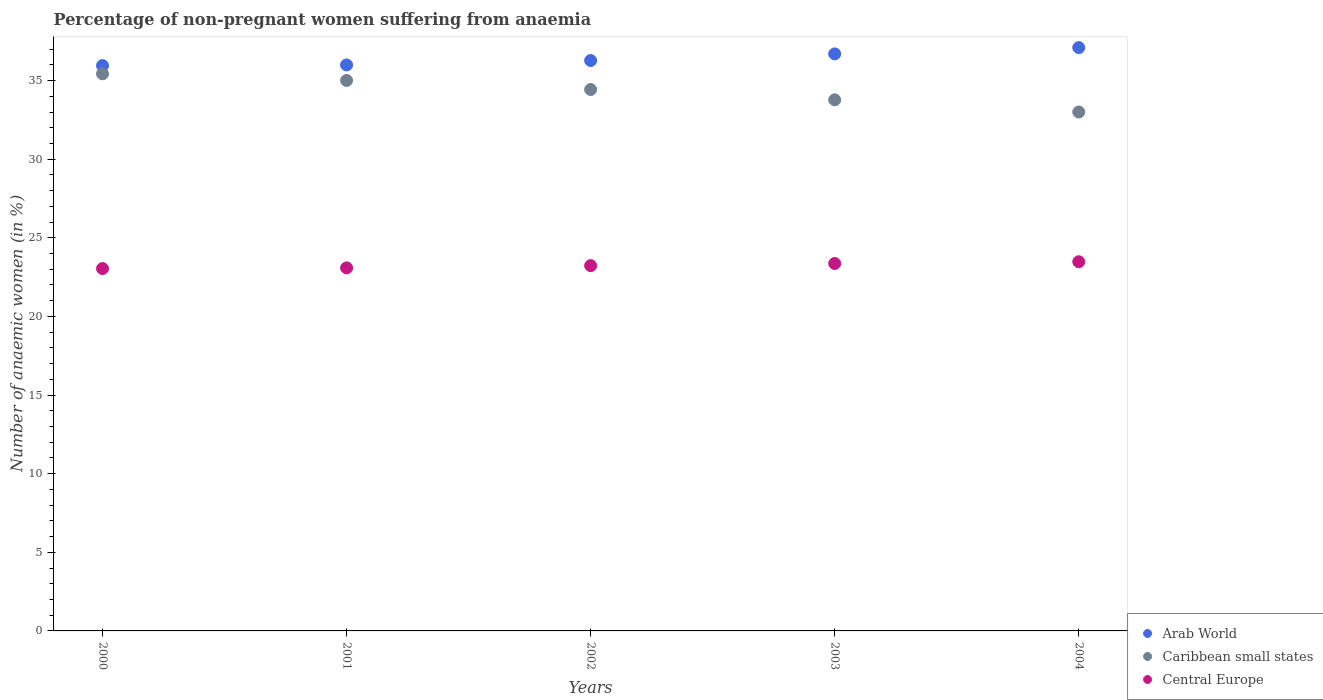What is the percentage of non-pregnant women suffering from anaemia in Arab World in 2000?
Your answer should be compact. 35.95. Across all years, what is the maximum percentage of non-pregnant women suffering from anaemia in Caribbean small states?
Offer a very short reply. 35.43. Across all years, what is the minimum percentage of non-pregnant women suffering from anaemia in Central Europe?
Give a very brief answer. 23.04. In which year was the percentage of non-pregnant women suffering from anaemia in Central Europe minimum?
Offer a terse response. 2000. What is the total percentage of non-pregnant women suffering from anaemia in Caribbean small states in the graph?
Provide a succinct answer. 171.65. What is the difference between the percentage of non-pregnant women suffering from anaemia in Central Europe in 2000 and that in 2003?
Provide a short and direct response. -0.32. What is the difference between the percentage of non-pregnant women suffering from anaemia in Arab World in 2002 and the percentage of non-pregnant women suffering from anaemia in Central Europe in 2000?
Provide a short and direct response. 13.23. What is the average percentage of non-pregnant women suffering from anaemia in Caribbean small states per year?
Your answer should be very brief. 34.33. In the year 2004, what is the difference between the percentage of non-pregnant women suffering from anaemia in Caribbean small states and percentage of non-pregnant women suffering from anaemia in Arab World?
Make the answer very short. -4.09. In how many years, is the percentage of non-pregnant women suffering from anaemia in Caribbean small states greater than 3 %?
Ensure brevity in your answer.  5. What is the ratio of the percentage of non-pregnant women suffering from anaemia in Central Europe in 2001 to that in 2003?
Offer a very short reply. 0.99. Is the difference between the percentage of non-pregnant women suffering from anaemia in Caribbean small states in 2002 and 2004 greater than the difference between the percentage of non-pregnant women suffering from anaemia in Arab World in 2002 and 2004?
Your response must be concise. Yes. What is the difference between the highest and the second highest percentage of non-pregnant women suffering from anaemia in Arab World?
Make the answer very short. 0.4. What is the difference between the highest and the lowest percentage of non-pregnant women suffering from anaemia in Caribbean small states?
Your answer should be compact. 2.43. In how many years, is the percentage of non-pregnant women suffering from anaemia in Arab World greater than the average percentage of non-pregnant women suffering from anaemia in Arab World taken over all years?
Your answer should be compact. 2. Is the sum of the percentage of non-pregnant women suffering from anaemia in Caribbean small states in 2000 and 2002 greater than the maximum percentage of non-pregnant women suffering from anaemia in Arab World across all years?
Make the answer very short. Yes. Is the percentage of non-pregnant women suffering from anaemia in Caribbean small states strictly greater than the percentage of non-pregnant women suffering from anaemia in Arab World over the years?
Offer a very short reply. No. What is the difference between two consecutive major ticks on the Y-axis?
Your answer should be very brief. 5. Are the values on the major ticks of Y-axis written in scientific E-notation?
Ensure brevity in your answer.  No. What is the title of the graph?
Your response must be concise. Percentage of non-pregnant women suffering from anaemia. Does "Other small states" appear as one of the legend labels in the graph?
Your answer should be very brief. No. What is the label or title of the X-axis?
Ensure brevity in your answer.  Years. What is the label or title of the Y-axis?
Make the answer very short. Number of anaemic women (in %). What is the Number of anaemic women (in %) in Arab World in 2000?
Make the answer very short. 35.95. What is the Number of anaemic women (in %) in Caribbean small states in 2000?
Ensure brevity in your answer.  35.43. What is the Number of anaemic women (in %) in Central Europe in 2000?
Give a very brief answer. 23.04. What is the Number of anaemic women (in %) in Arab World in 2001?
Offer a very short reply. 35.99. What is the Number of anaemic women (in %) of Caribbean small states in 2001?
Give a very brief answer. 35.01. What is the Number of anaemic women (in %) of Central Europe in 2001?
Make the answer very short. 23.09. What is the Number of anaemic women (in %) of Arab World in 2002?
Your response must be concise. 36.27. What is the Number of anaemic women (in %) in Caribbean small states in 2002?
Your answer should be compact. 34.43. What is the Number of anaemic women (in %) in Central Europe in 2002?
Give a very brief answer. 23.23. What is the Number of anaemic women (in %) of Arab World in 2003?
Provide a succinct answer. 36.7. What is the Number of anaemic women (in %) of Caribbean small states in 2003?
Provide a succinct answer. 33.78. What is the Number of anaemic women (in %) in Central Europe in 2003?
Offer a very short reply. 23.37. What is the Number of anaemic women (in %) in Arab World in 2004?
Make the answer very short. 37.1. What is the Number of anaemic women (in %) of Caribbean small states in 2004?
Make the answer very short. 33. What is the Number of anaemic women (in %) of Central Europe in 2004?
Keep it short and to the point. 23.48. Across all years, what is the maximum Number of anaemic women (in %) in Arab World?
Make the answer very short. 37.1. Across all years, what is the maximum Number of anaemic women (in %) in Caribbean small states?
Provide a short and direct response. 35.43. Across all years, what is the maximum Number of anaemic women (in %) of Central Europe?
Your answer should be very brief. 23.48. Across all years, what is the minimum Number of anaemic women (in %) of Arab World?
Offer a very short reply. 35.95. Across all years, what is the minimum Number of anaemic women (in %) in Caribbean small states?
Ensure brevity in your answer.  33. Across all years, what is the minimum Number of anaemic women (in %) in Central Europe?
Offer a terse response. 23.04. What is the total Number of anaemic women (in %) of Arab World in the graph?
Your response must be concise. 182.01. What is the total Number of anaemic women (in %) of Caribbean small states in the graph?
Your response must be concise. 171.65. What is the total Number of anaemic women (in %) of Central Europe in the graph?
Provide a succinct answer. 116.21. What is the difference between the Number of anaemic women (in %) in Arab World in 2000 and that in 2001?
Offer a terse response. -0.04. What is the difference between the Number of anaemic women (in %) of Caribbean small states in 2000 and that in 2001?
Provide a short and direct response. 0.43. What is the difference between the Number of anaemic women (in %) of Central Europe in 2000 and that in 2001?
Offer a very short reply. -0.04. What is the difference between the Number of anaemic women (in %) in Arab World in 2000 and that in 2002?
Provide a short and direct response. -0.32. What is the difference between the Number of anaemic women (in %) in Caribbean small states in 2000 and that in 2002?
Keep it short and to the point. 1. What is the difference between the Number of anaemic women (in %) in Central Europe in 2000 and that in 2002?
Offer a terse response. -0.19. What is the difference between the Number of anaemic women (in %) in Arab World in 2000 and that in 2003?
Your response must be concise. -0.74. What is the difference between the Number of anaemic women (in %) in Caribbean small states in 2000 and that in 2003?
Make the answer very short. 1.66. What is the difference between the Number of anaemic women (in %) in Central Europe in 2000 and that in 2003?
Offer a terse response. -0.32. What is the difference between the Number of anaemic women (in %) of Arab World in 2000 and that in 2004?
Offer a terse response. -1.14. What is the difference between the Number of anaemic women (in %) in Caribbean small states in 2000 and that in 2004?
Offer a terse response. 2.43. What is the difference between the Number of anaemic women (in %) in Central Europe in 2000 and that in 2004?
Offer a very short reply. -0.43. What is the difference between the Number of anaemic women (in %) in Arab World in 2001 and that in 2002?
Make the answer very short. -0.28. What is the difference between the Number of anaemic women (in %) in Caribbean small states in 2001 and that in 2002?
Ensure brevity in your answer.  0.58. What is the difference between the Number of anaemic women (in %) in Central Europe in 2001 and that in 2002?
Your answer should be compact. -0.14. What is the difference between the Number of anaemic women (in %) of Arab World in 2001 and that in 2003?
Provide a succinct answer. -0.7. What is the difference between the Number of anaemic women (in %) of Caribbean small states in 2001 and that in 2003?
Your response must be concise. 1.23. What is the difference between the Number of anaemic women (in %) in Central Europe in 2001 and that in 2003?
Offer a very short reply. -0.28. What is the difference between the Number of anaemic women (in %) in Arab World in 2001 and that in 2004?
Ensure brevity in your answer.  -1.1. What is the difference between the Number of anaemic women (in %) in Caribbean small states in 2001 and that in 2004?
Your answer should be very brief. 2. What is the difference between the Number of anaemic women (in %) in Central Europe in 2001 and that in 2004?
Give a very brief answer. -0.39. What is the difference between the Number of anaemic women (in %) of Arab World in 2002 and that in 2003?
Make the answer very short. -0.42. What is the difference between the Number of anaemic women (in %) of Caribbean small states in 2002 and that in 2003?
Your answer should be very brief. 0.66. What is the difference between the Number of anaemic women (in %) of Central Europe in 2002 and that in 2003?
Offer a terse response. -0.14. What is the difference between the Number of anaemic women (in %) of Arab World in 2002 and that in 2004?
Your answer should be very brief. -0.82. What is the difference between the Number of anaemic women (in %) in Caribbean small states in 2002 and that in 2004?
Ensure brevity in your answer.  1.43. What is the difference between the Number of anaemic women (in %) in Central Europe in 2002 and that in 2004?
Offer a terse response. -0.25. What is the difference between the Number of anaemic women (in %) of Arab World in 2003 and that in 2004?
Ensure brevity in your answer.  -0.4. What is the difference between the Number of anaemic women (in %) in Caribbean small states in 2003 and that in 2004?
Your response must be concise. 0.77. What is the difference between the Number of anaemic women (in %) of Central Europe in 2003 and that in 2004?
Provide a succinct answer. -0.11. What is the difference between the Number of anaemic women (in %) in Arab World in 2000 and the Number of anaemic women (in %) in Caribbean small states in 2001?
Make the answer very short. 0.95. What is the difference between the Number of anaemic women (in %) in Arab World in 2000 and the Number of anaemic women (in %) in Central Europe in 2001?
Give a very brief answer. 12.86. What is the difference between the Number of anaemic women (in %) in Caribbean small states in 2000 and the Number of anaemic women (in %) in Central Europe in 2001?
Provide a succinct answer. 12.34. What is the difference between the Number of anaemic women (in %) of Arab World in 2000 and the Number of anaemic women (in %) of Caribbean small states in 2002?
Keep it short and to the point. 1.52. What is the difference between the Number of anaemic women (in %) of Arab World in 2000 and the Number of anaemic women (in %) of Central Europe in 2002?
Give a very brief answer. 12.72. What is the difference between the Number of anaemic women (in %) of Caribbean small states in 2000 and the Number of anaemic women (in %) of Central Europe in 2002?
Ensure brevity in your answer.  12.2. What is the difference between the Number of anaemic women (in %) in Arab World in 2000 and the Number of anaemic women (in %) in Caribbean small states in 2003?
Offer a terse response. 2.18. What is the difference between the Number of anaemic women (in %) of Arab World in 2000 and the Number of anaemic women (in %) of Central Europe in 2003?
Your answer should be very brief. 12.58. What is the difference between the Number of anaemic women (in %) of Caribbean small states in 2000 and the Number of anaemic women (in %) of Central Europe in 2003?
Give a very brief answer. 12.06. What is the difference between the Number of anaemic women (in %) in Arab World in 2000 and the Number of anaemic women (in %) in Caribbean small states in 2004?
Provide a short and direct response. 2.95. What is the difference between the Number of anaemic women (in %) of Arab World in 2000 and the Number of anaemic women (in %) of Central Europe in 2004?
Provide a short and direct response. 12.47. What is the difference between the Number of anaemic women (in %) of Caribbean small states in 2000 and the Number of anaemic women (in %) of Central Europe in 2004?
Give a very brief answer. 11.95. What is the difference between the Number of anaemic women (in %) in Arab World in 2001 and the Number of anaemic women (in %) in Caribbean small states in 2002?
Your response must be concise. 1.56. What is the difference between the Number of anaemic women (in %) in Arab World in 2001 and the Number of anaemic women (in %) in Central Europe in 2002?
Provide a succinct answer. 12.76. What is the difference between the Number of anaemic women (in %) in Caribbean small states in 2001 and the Number of anaemic women (in %) in Central Europe in 2002?
Ensure brevity in your answer.  11.78. What is the difference between the Number of anaemic women (in %) of Arab World in 2001 and the Number of anaemic women (in %) of Caribbean small states in 2003?
Your response must be concise. 2.22. What is the difference between the Number of anaemic women (in %) in Arab World in 2001 and the Number of anaemic women (in %) in Central Europe in 2003?
Your answer should be compact. 12.63. What is the difference between the Number of anaemic women (in %) of Caribbean small states in 2001 and the Number of anaemic women (in %) of Central Europe in 2003?
Give a very brief answer. 11.64. What is the difference between the Number of anaemic women (in %) in Arab World in 2001 and the Number of anaemic women (in %) in Caribbean small states in 2004?
Offer a terse response. 2.99. What is the difference between the Number of anaemic women (in %) in Arab World in 2001 and the Number of anaemic women (in %) in Central Europe in 2004?
Your answer should be very brief. 12.52. What is the difference between the Number of anaemic women (in %) of Caribbean small states in 2001 and the Number of anaemic women (in %) of Central Europe in 2004?
Your answer should be compact. 11.53. What is the difference between the Number of anaemic women (in %) of Arab World in 2002 and the Number of anaemic women (in %) of Caribbean small states in 2003?
Your answer should be compact. 2.5. What is the difference between the Number of anaemic women (in %) of Arab World in 2002 and the Number of anaemic women (in %) of Central Europe in 2003?
Ensure brevity in your answer.  12.91. What is the difference between the Number of anaemic women (in %) of Caribbean small states in 2002 and the Number of anaemic women (in %) of Central Europe in 2003?
Keep it short and to the point. 11.06. What is the difference between the Number of anaemic women (in %) of Arab World in 2002 and the Number of anaemic women (in %) of Caribbean small states in 2004?
Offer a very short reply. 3.27. What is the difference between the Number of anaemic women (in %) in Arab World in 2002 and the Number of anaemic women (in %) in Central Europe in 2004?
Your answer should be very brief. 12.8. What is the difference between the Number of anaemic women (in %) of Caribbean small states in 2002 and the Number of anaemic women (in %) of Central Europe in 2004?
Offer a terse response. 10.95. What is the difference between the Number of anaemic women (in %) of Arab World in 2003 and the Number of anaemic women (in %) of Caribbean small states in 2004?
Your answer should be very brief. 3.69. What is the difference between the Number of anaemic women (in %) in Arab World in 2003 and the Number of anaemic women (in %) in Central Europe in 2004?
Provide a succinct answer. 13.22. What is the difference between the Number of anaemic women (in %) in Caribbean small states in 2003 and the Number of anaemic women (in %) in Central Europe in 2004?
Your answer should be very brief. 10.3. What is the average Number of anaemic women (in %) in Arab World per year?
Your response must be concise. 36.4. What is the average Number of anaemic women (in %) in Caribbean small states per year?
Keep it short and to the point. 34.33. What is the average Number of anaemic women (in %) of Central Europe per year?
Give a very brief answer. 23.24. In the year 2000, what is the difference between the Number of anaemic women (in %) in Arab World and Number of anaemic women (in %) in Caribbean small states?
Ensure brevity in your answer.  0.52. In the year 2000, what is the difference between the Number of anaemic women (in %) in Arab World and Number of anaemic women (in %) in Central Europe?
Keep it short and to the point. 12.91. In the year 2000, what is the difference between the Number of anaemic women (in %) of Caribbean small states and Number of anaemic women (in %) of Central Europe?
Offer a very short reply. 12.39. In the year 2001, what is the difference between the Number of anaemic women (in %) of Arab World and Number of anaemic women (in %) of Caribbean small states?
Your response must be concise. 0.99. In the year 2001, what is the difference between the Number of anaemic women (in %) in Arab World and Number of anaemic women (in %) in Central Europe?
Offer a terse response. 12.9. In the year 2001, what is the difference between the Number of anaemic women (in %) in Caribbean small states and Number of anaemic women (in %) in Central Europe?
Provide a succinct answer. 11.92. In the year 2002, what is the difference between the Number of anaemic women (in %) of Arab World and Number of anaemic women (in %) of Caribbean small states?
Provide a succinct answer. 1.84. In the year 2002, what is the difference between the Number of anaemic women (in %) of Arab World and Number of anaemic women (in %) of Central Europe?
Offer a terse response. 13.04. In the year 2002, what is the difference between the Number of anaemic women (in %) in Caribbean small states and Number of anaemic women (in %) in Central Europe?
Your answer should be compact. 11.2. In the year 2003, what is the difference between the Number of anaemic women (in %) of Arab World and Number of anaemic women (in %) of Caribbean small states?
Keep it short and to the point. 2.92. In the year 2003, what is the difference between the Number of anaemic women (in %) in Arab World and Number of anaemic women (in %) in Central Europe?
Your response must be concise. 13.33. In the year 2003, what is the difference between the Number of anaemic women (in %) in Caribbean small states and Number of anaemic women (in %) in Central Europe?
Make the answer very short. 10.41. In the year 2004, what is the difference between the Number of anaemic women (in %) of Arab World and Number of anaemic women (in %) of Caribbean small states?
Offer a terse response. 4.09. In the year 2004, what is the difference between the Number of anaemic women (in %) in Arab World and Number of anaemic women (in %) in Central Europe?
Your answer should be compact. 13.62. In the year 2004, what is the difference between the Number of anaemic women (in %) of Caribbean small states and Number of anaemic women (in %) of Central Europe?
Give a very brief answer. 9.52. What is the ratio of the Number of anaemic women (in %) of Arab World in 2000 to that in 2001?
Make the answer very short. 1. What is the ratio of the Number of anaemic women (in %) in Caribbean small states in 2000 to that in 2001?
Your answer should be very brief. 1.01. What is the ratio of the Number of anaemic women (in %) in Central Europe in 2000 to that in 2001?
Keep it short and to the point. 1. What is the ratio of the Number of anaemic women (in %) in Caribbean small states in 2000 to that in 2002?
Make the answer very short. 1.03. What is the ratio of the Number of anaemic women (in %) of Arab World in 2000 to that in 2003?
Provide a short and direct response. 0.98. What is the ratio of the Number of anaemic women (in %) of Caribbean small states in 2000 to that in 2003?
Offer a very short reply. 1.05. What is the ratio of the Number of anaemic women (in %) of Central Europe in 2000 to that in 2003?
Your response must be concise. 0.99. What is the ratio of the Number of anaemic women (in %) in Arab World in 2000 to that in 2004?
Ensure brevity in your answer.  0.97. What is the ratio of the Number of anaemic women (in %) of Caribbean small states in 2000 to that in 2004?
Ensure brevity in your answer.  1.07. What is the ratio of the Number of anaemic women (in %) in Central Europe in 2000 to that in 2004?
Make the answer very short. 0.98. What is the ratio of the Number of anaemic women (in %) of Arab World in 2001 to that in 2002?
Provide a succinct answer. 0.99. What is the ratio of the Number of anaemic women (in %) in Caribbean small states in 2001 to that in 2002?
Give a very brief answer. 1.02. What is the ratio of the Number of anaemic women (in %) of Arab World in 2001 to that in 2003?
Make the answer very short. 0.98. What is the ratio of the Number of anaemic women (in %) in Caribbean small states in 2001 to that in 2003?
Offer a very short reply. 1.04. What is the ratio of the Number of anaemic women (in %) of Central Europe in 2001 to that in 2003?
Your answer should be compact. 0.99. What is the ratio of the Number of anaemic women (in %) in Arab World in 2001 to that in 2004?
Provide a succinct answer. 0.97. What is the ratio of the Number of anaemic women (in %) in Caribbean small states in 2001 to that in 2004?
Your response must be concise. 1.06. What is the ratio of the Number of anaemic women (in %) in Central Europe in 2001 to that in 2004?
Offer a very short reply. 0.98. What is the ratio of the Number of anaemic women (in %) of Arab World in 2002 to that in 2003?
Provide a succinct answer. 0.99. What is the ratio of the Number of anaemic women (in %) in Caribbean small states in 2002 to that in 2003?
Provide a short and direct response. 1.02. What is the ratio of the Number of anaemic women (in %) in Arab World in 2002 to that in 2004?
Keep it short and to the point. 0.98. What is the ratio of the Number of anaemic women (in %) in Caribbean small states in 2002 to that in 2004?
Provide a short and direct response. 1.04. What is the ratio of the Number of anaemic women (in %) of Central Europe in 2002 to that in 2004?
Ensure brevity in your answer.  0.99. What is the ratio of the Number of anaemic women (in %) of Caribbean small states in 2003 to that in 2004?
Your answer should be compact. 1.02. What is the ratio of the Number of anaemic women (in %) of Central Europe in 2003 to that in 2004?
Offer a very short reply. 1. What is the difference between the highest and the second highest Number of anaemic women (in %) in Arab World?
Keep it short and to the point. 0.4. What is the difference between the highest and the second highest Number of anaemic women (in %) in Caribbean small states?
Ensure brevity in your answer.  0.43. What is the difference between the highest and the second highest Number of anaemic women (in %) of Central Europe?
Provide a succinct answer. 0.11. What is the difference between the highest and the lowest Number of anaemic women (in %) in Arab World?
Give a very brief answer. 1.14. What is the difference between the highest and the lowest Number of anaemic women (in %) of Caribbean small states?
Ensure brevity in your answer.  2.43. What is the difference between the highest and the lowest Number of anaemic women (in %) in Central Europe?
Ensure brevity in your answer.  0.43. 